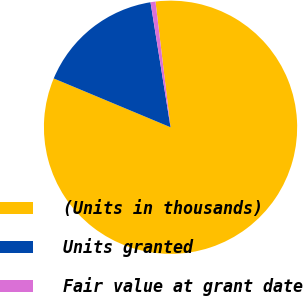Convert chart. <chart><loc_0><loc_0><loc_500><loc_500><pie_chart><fcel>(Units in thousands)<fcel>Units granted<fcel>Fair value at grant date<nl><fcel>83.2%<fcel>16.17%<fcel>0.63%<nl></chart> 